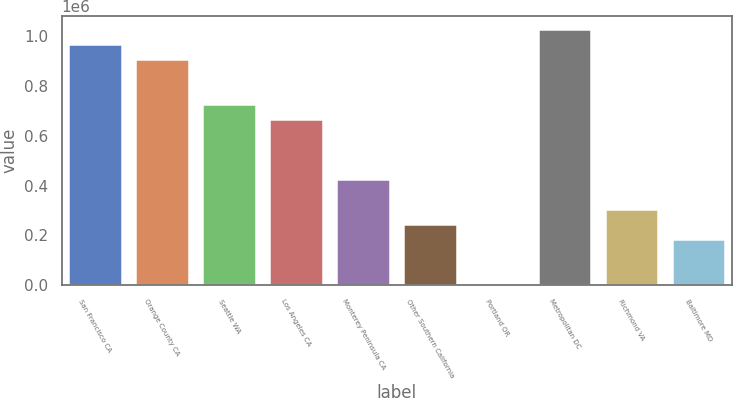Convert chart to OTSL. <chart><loc_0><loc_0><loc_500><loc_500><bar_chart><fcel>San Francisco CA<fcel>Orange County CA<fcel>Seattle WA<fcel>Los Angeles CA<fcel>Monterey Peninsula CA<fcel>Other Southern California<fcel>Portland OR<fcel>Metropolitan DC<fcel>Richmond VA<fcel>Baltimore MD<nl><fcel>968214<fcel>908102<fcel>727767<fcel>667655<fcel>427208<fcel>246872<fcel>6425<fcel>1.02833e+06<fcel>306984<fcel>186760<nl></chart> 